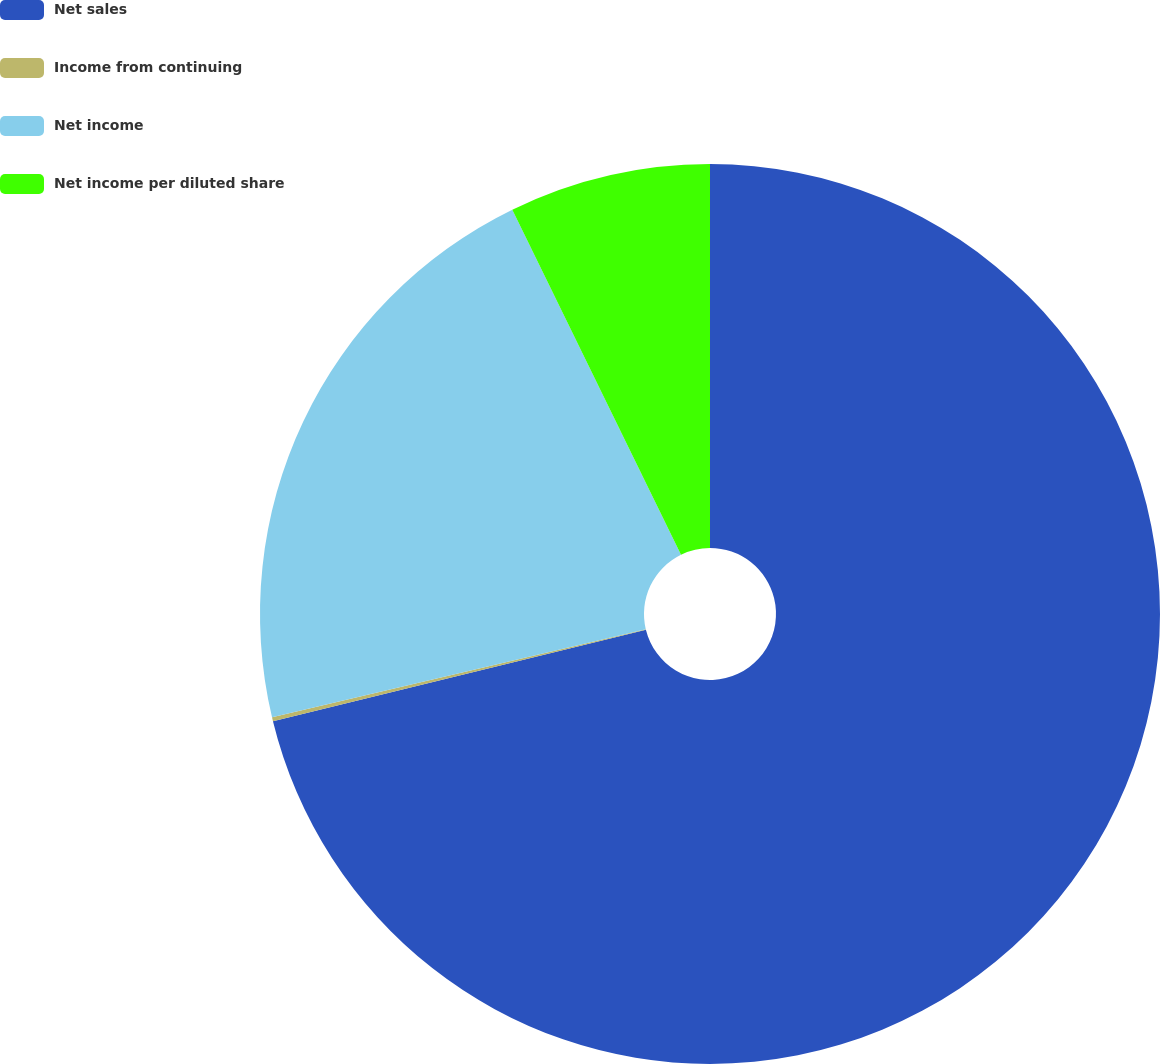Convert chart. <chart><loc_0><loc_0><loc_500><loc_500><pie_chart><fcel>Net sales<fcel>Income from continuing<fcel>Net income<fcel>Net income per diluted share<nl><fcel>71.18%<fcel>0.14%<fcel>21.45%<fcel>7.24%<nl></chart> 